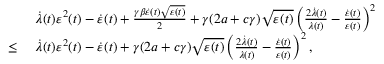Convert formula to latex. <formula><loc_0><loc_0><loc_500><loc_500>\begin{array} { r l } & { \dot { \lambda } ( t ) \varepsilon ^ { 2 } ( t ) - \dot { \varepsilon } ( t ) + \frac { \gamma \beta \dot { \varepsilon } ( t ) \sqrt { \varepsilon ( t ) } } { 2 } + \gamma ( 2 a + c \gamma ) \sqrt { \varepsilon ( t ) } \left ( \frac { 2 \dot { \lambda } ( t ) } { \lambda ( t ) } - \frac { \dot { \varepsilon } ( t ) } { \varepsilon ( t ) } \right ) ^ { 2 } } \\ { \leq \ } & { \dot { \lambda } ( t ) \varepsilon ^ { 2 } ( t ) - \dot { \varepsilon } ( t ) + \gamma ( 2 a + c \gamma ) \sqrt { \varepsilon ( t ) } \left ( \frac { 2 \dot { \lambda } ( t ) } { \lambda ( t ) } - \frac { \dot { \varepsilon } ( t ) } { \varepsilon ( t ) } \right ) ^ { 2 } , } \end{array}</formula> 